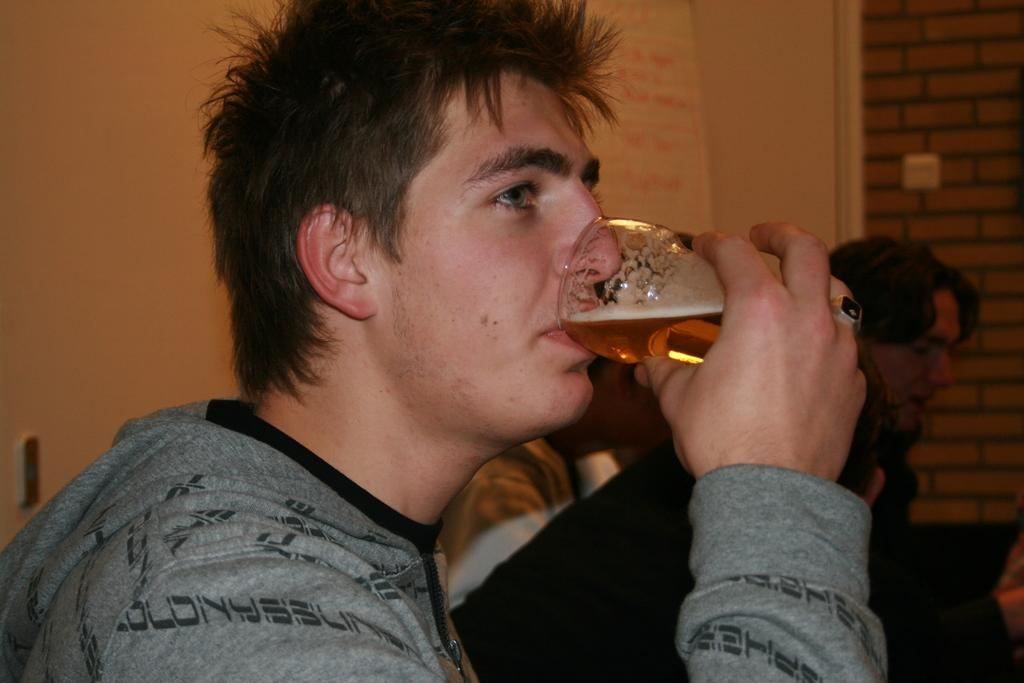How many people are in the image? There is a group of people in the image. What are the people wearing? The people are wearing dresses. Can you describe any specific actions or objects being held by the people? One person is holding a glass. What can be seen in the background of the image? There is a white and brown color brick wall in the background of the image. What type of sand can be seen on the ground in the image? There is no sand visible in the image; it features a group of people wearing dresses, one of whom is holding a glass, and a brick wall in the background. 